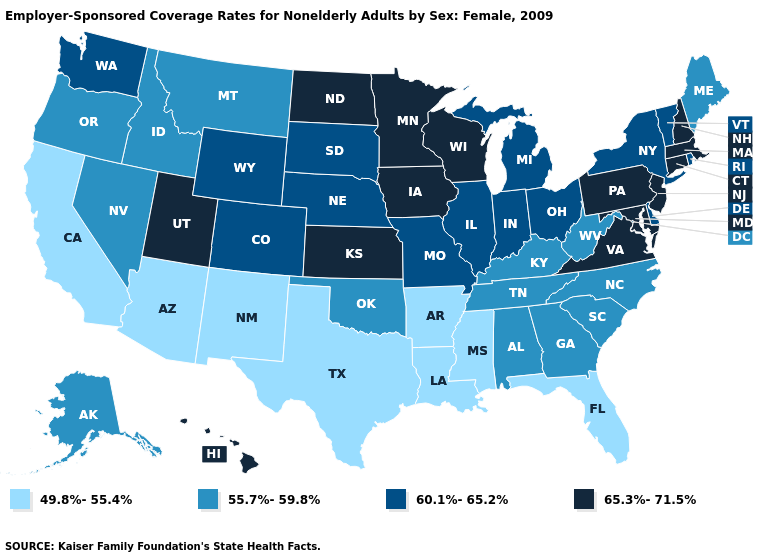What is the value of Rhode Island?
Quick response, please. 60.1%-65.2%. What is the lowest value in the Northeast?
Concise answer only. 55.7%-59.8%. Does the first symbol in the legend represent the smallest category?
Quick response, please. Yes. What is the lowest value in the USA?
Concise answer only. 49.8%-55.4%. Among the states that border Wisconsin , which have the highest value?
Quick response, please. Iowa, Minnesota. Name the states that have a value in the range 65.3%-71.5%?
Concise answer only. Connecticut, Hawaii, Iowa, Kansas, Maryland, Massachusetts, Minnesota, New Hampshire, New Jersey, North Dakota, Pennsylvania, Utah, Virginia, Wisconsin. Name the states that have a value in the range 49.8%-55.4%?
Answer briefly. Arizona, Arkansas, California, Florida, Louisiana, Mississippi, New Mexico, Texas. What is the lowest value in the USA?
Answer briefly. 49.8%-55.4%. What is the value of Colorado?
Short answer required. 60.1%-65.2%. What is the lowest value in the Northeast?
Write a very short answer. 55.7%-59.8%. Which states have the lowest value in the USA?
Answer briefly. Arizona, Arkansas, California, Florida, Louisiana, Mississippi, New Mexico, Texas. Name the states that have a value in the range 60.1%-65.2%?
Write a very short answer. Colorado, Delaware, Illinois, Indiana, Michigan, Missouri, Nebraska, New York, Ohio, Rhode Island, South Dakota, Vermont, Washington, Wyoming. Which states have the lowest value in the USA?
Keep it brief. Arizona, Arkansas, California, Florida, Louisiana, Mississippi, New Mexico, Texas. How many symbols are there in the legend?
Give a very brief answer. 4. 